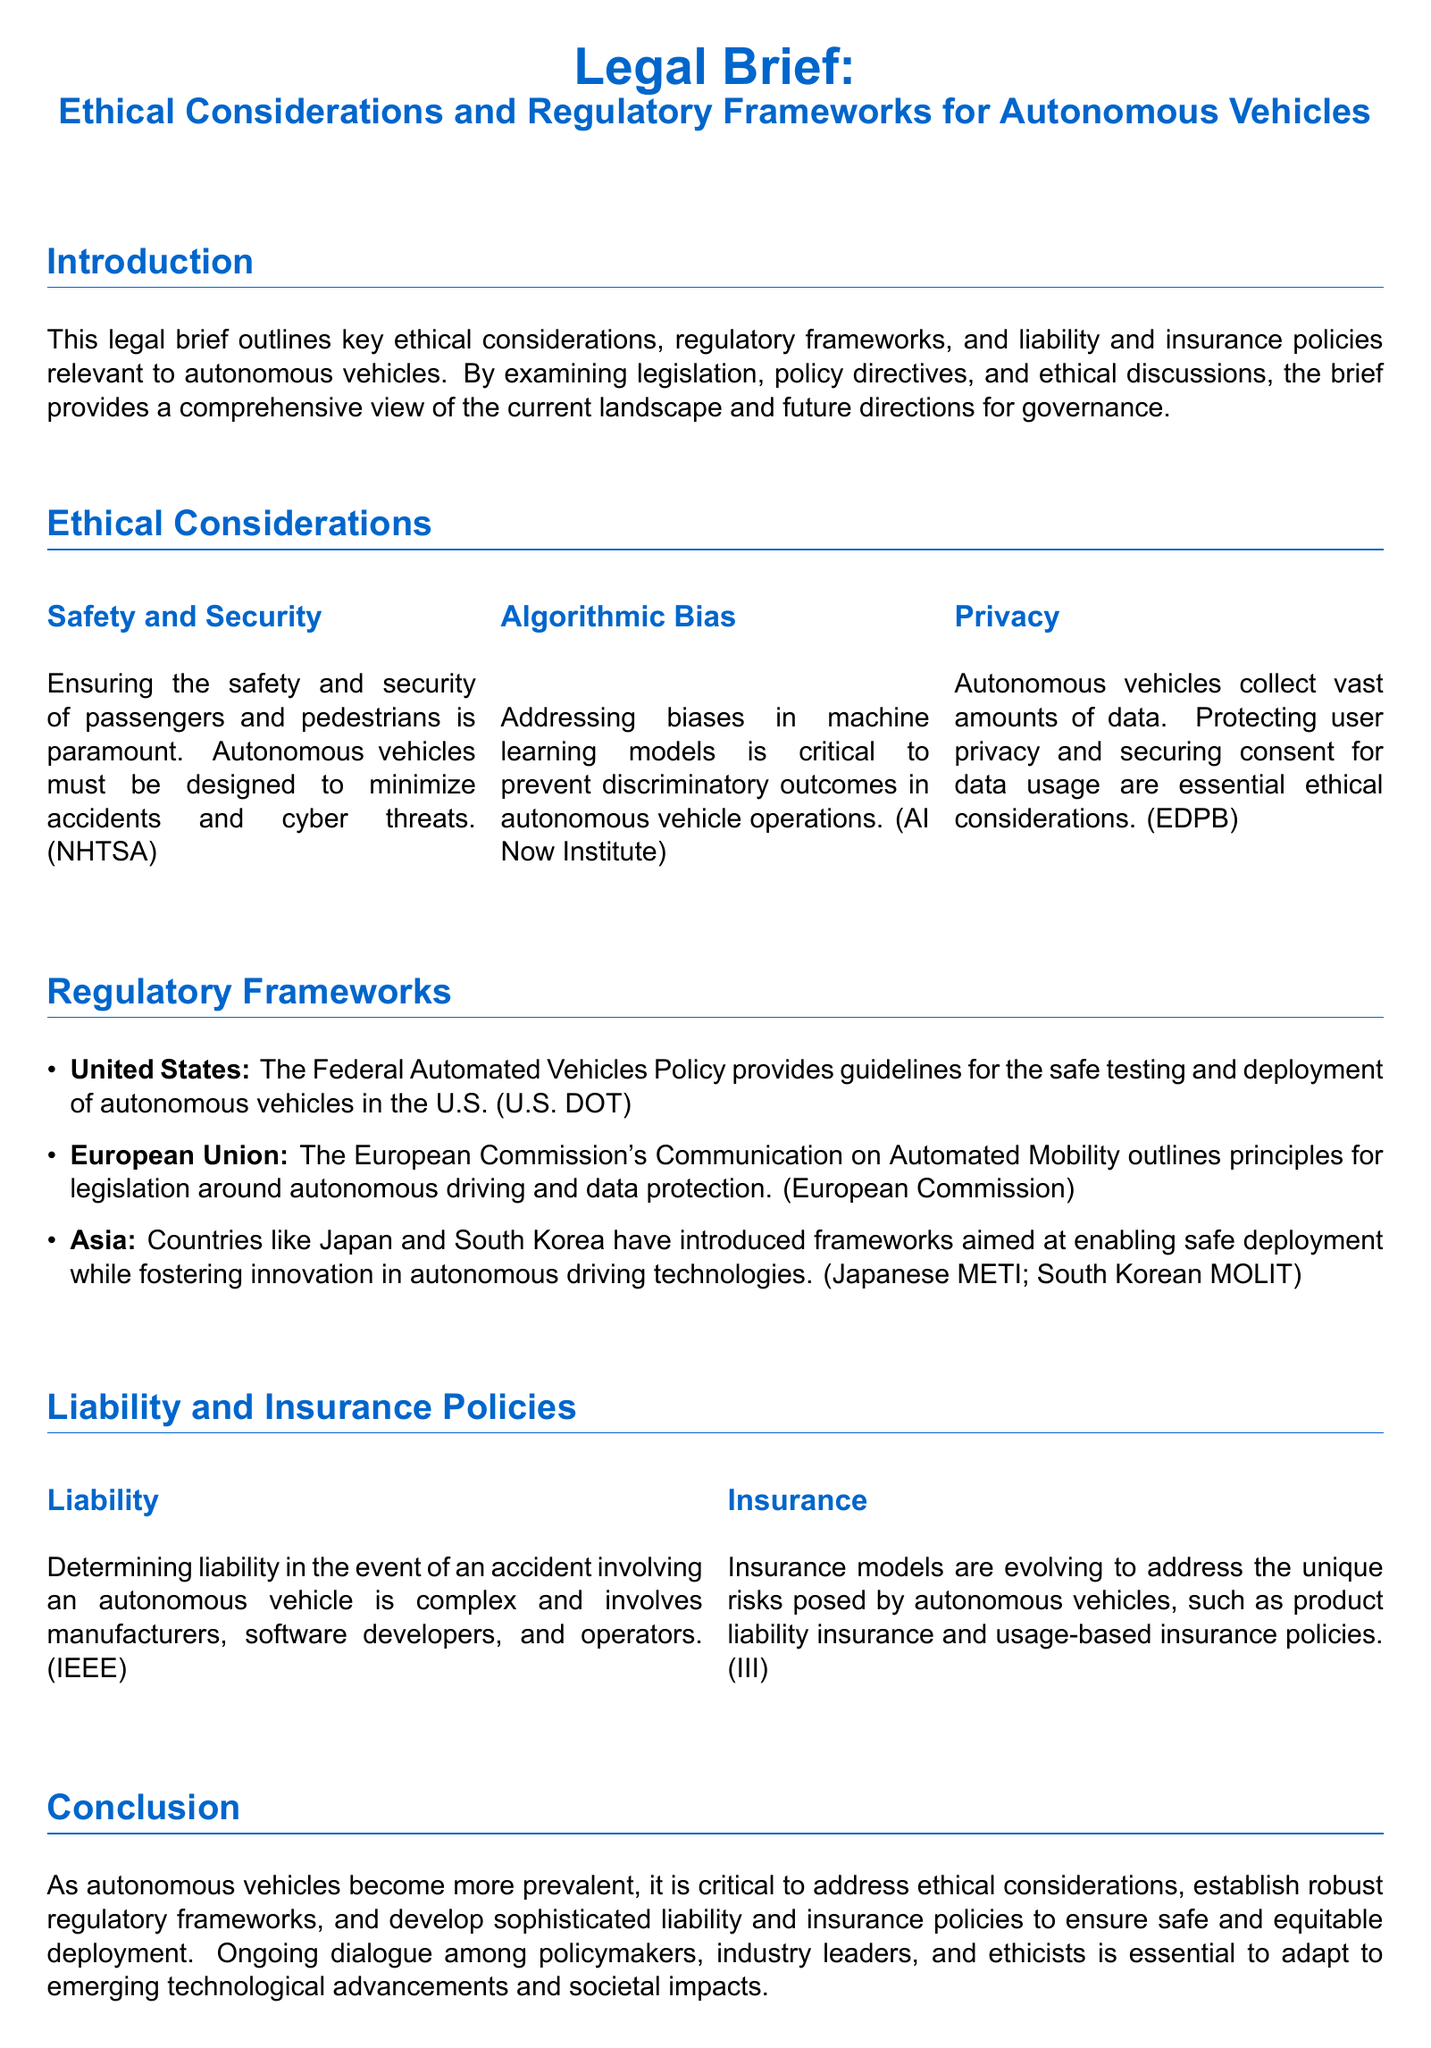What are the ethical considerations related to safety? The brief highlights that ensuring the safety and security of passengers and pedestrians is paramount.
Answer: Safety and Security What is one critical aspect of algorithmic bias? The brief states that addressing biases in machine learning models is critical to prevent discriminatory outcomes.
Answer: Discriminatory outcomes Which U.S. policy provides guidelines for autonomous vehicles? The brief mentions the Federal Automated Vehicles Policy as a guideline for safe testing and deployment in the U.S.
Answer: Federal Automated Vehicles Policy What principle does the European Commission's Communication address? The brief details that it outlines principles for legislation around autonomous driving and data protection.
Answer: Legislation around autonomous driving and data protection Who are the parties involved in determining liability? The brief indicates that manufacturers, software developers, and operators are involved in determining liability for accidents.
Answer: Manufacturers, software developers, and operators What type of insurance models are evolving for autonomous vehicles? The brief notes that insurance models like product liability insurance and usage-based insurance policies are evolving.
Answer: Product liability insurance and usage-based insurance policies What is essential for autonomous vehicles according to the conclusion? The brief emphasizes the need to address ethical considerations, establish robust regulatory frameworks, and develop sophisticated liability and insurance policies.
Answer: Ethical considerations, regulatory frameworks, and insurance policies What is the role of ongoing dialogue in the context of autonomous vehicles? The brief states that ongoing dialogue among policymakers, industry leaders, and ethicists is essential to adapt to emerging technological advancements and societal impacts.
Answer: Adapt to emerging technological advancements and societal impacts 